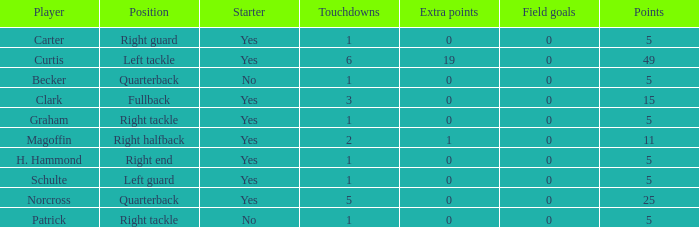Name the extra points for left guard 0.0. 